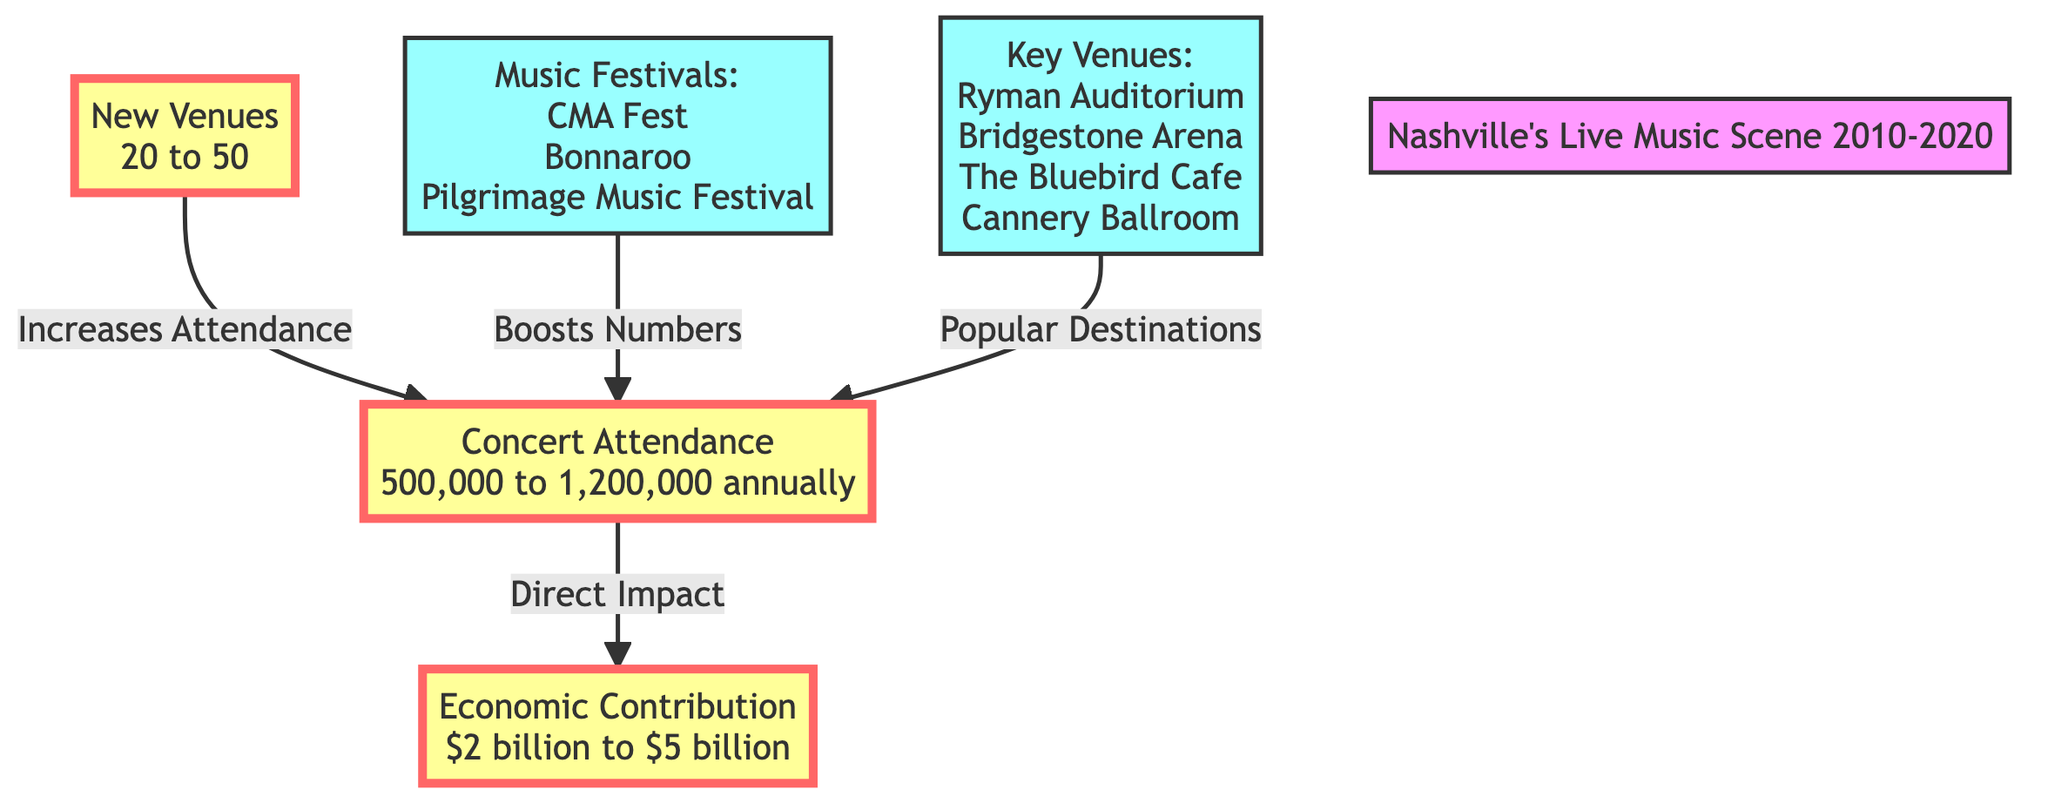What was the range of concert attendance from 2010 to 2020? The diagram indicates that concert attendance ranged from 500,000 to 1,200,000 annually. This is found directly within the "Concert Attendance" node in the diagram.
Answer: 500,000 to 1,200,000 annually What was the economic contribution of Nashville's live music scene in 2020? The economic contribution is specified in the "Economic Contribution" node as ranging from $2 billion to $5 billion. This value is explicitly stated within the diagram, reflecting the financial impact of the music scene.
Answer: $2 billion to $5 billion How many new venues were established according to the data from 2010 to 2020? The diagram shows that the number of new venues ranged from 20 to 50. This figure is directly provided in the "New Venues" node of the diagram, highlighting the growth in the music venue landscape.
Answer: 20 to 50 What relationship exists between new venues and concert attendance? The diagram illustrates that new venues contribute to increased concert attendance. This relationship is represented as an arrow pointing from "New Venues" to "Concert Attendance" with the label "Increases Attendance".
Answer: Increases Attendance How do music festivals impact concert attendance numbers? The diagram indicates that music festivals boost concert attendance, as shown by the arrow from "Music Festivals" to "Concert Attendance", labeled as "Boosts Numbers". This relationship emphasizes the role of festivals in driving attendance.
Answer: Boosts Numbers What is a key venue listed in the diagram? The diagram lists several key venues, including Ryman Auditorium, Bridgestone Arena, The Bluebird Cafe, and Cannery Ballroom. These are collectively noted in the "Key Venues" node, from which any of these can be derived.
Answer: Ryman Auditorium How does the economic contribution relate to concert attendance? The diagram shows a direct impact relationship where concert attendance affects economic contribution. This is represented by an arrow from "Concert Attendance" to "Economic Contribution", indicating that higher attendance may lead to greater economic impact.
Answer: Direct Impact What are some of the music festivals mentioned in this growth period? The diagram references several music festivals, including CMA Fest, Bonnaroo, and Pilgrimage Music Festival. These are listed under the "Music Festivals" node, showcasing the events contributing to the scene's vibrancy.
Answer: CMA Fest, Bonnaroo, Pilgrimage Music Festival 